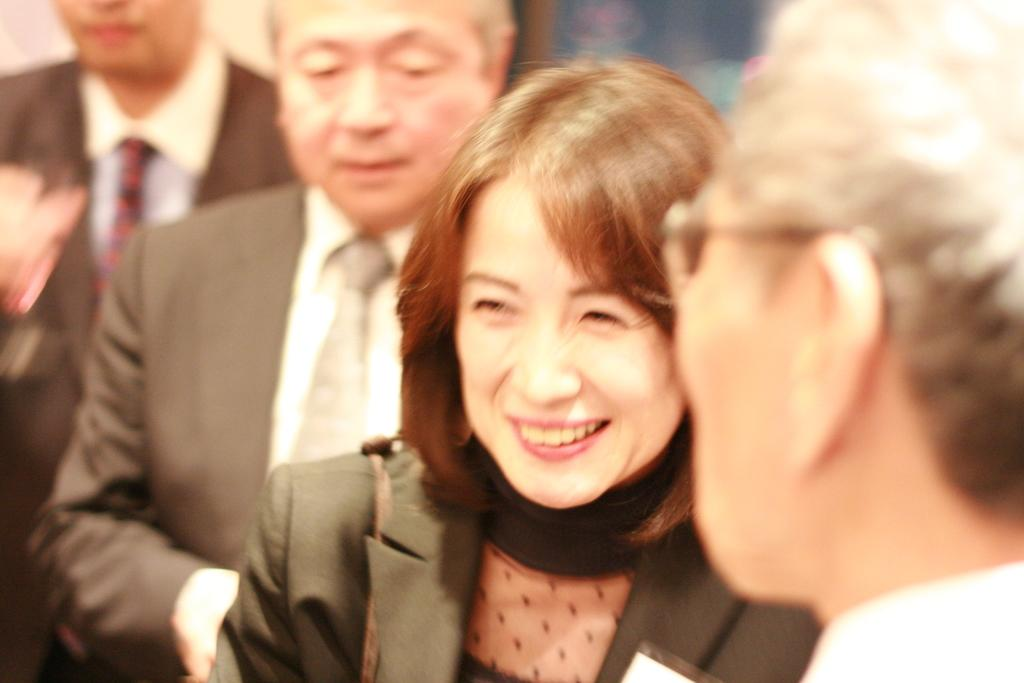How many people are in the image? There are four persons in the image. Can you describe one of the individuals in the image? Among the four persons, there is a woman. What is the woman doing in the image? The woman is smiling. What type of tent can be seen in the background of the image? There is no tent present in the image. What trick is the woman performing in the image? The woman is not performing any trick in the image; she is simply smiling. 